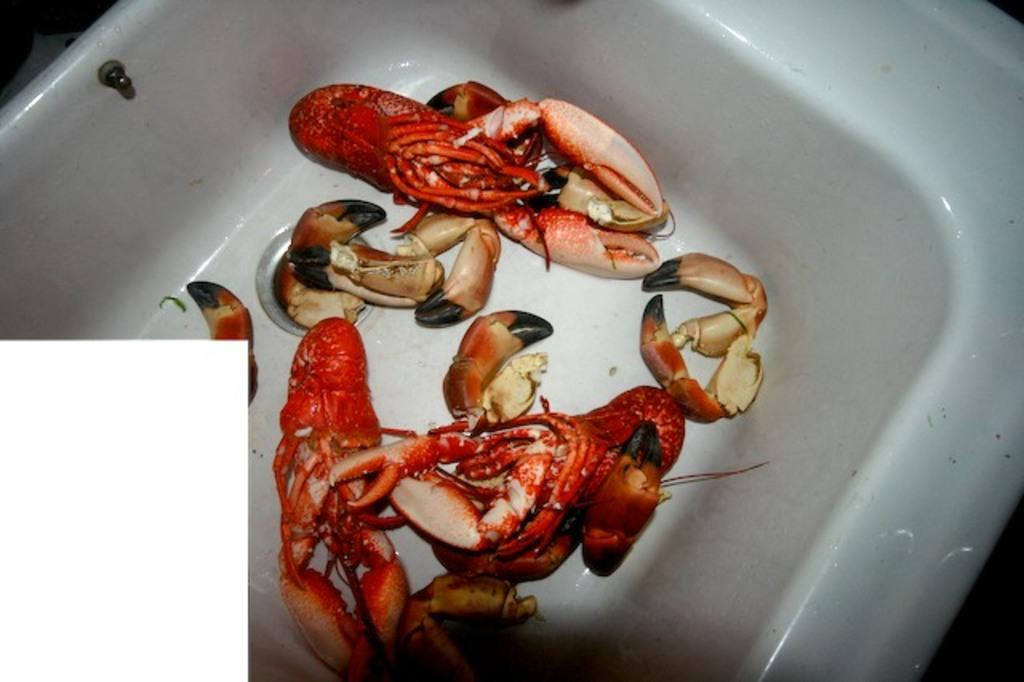What can be found in the image? There is a washbasin in the image. What is inside the washbasin? There are crabs present in the washbasin. What type of committee can be seen meeting in the image? There is no committee present in the image; it features a washbasin with crabs. Can you tell me what kind of shoe is being used as a notebook in the image? There is no shoe or notebook present in the image; it only contains a washbasin with crabs. 